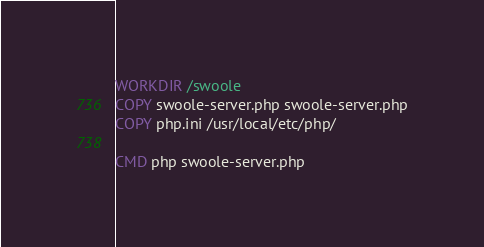<code> <loc_0><loc_0><loc_500><loc_500><_Dockerfile_>
WORKDIR /swoole
COPY swoole-server.php swoole-server.php
COPY php.ini /usr/local/etc/php/

CMD php swoole-server.php
</code> 